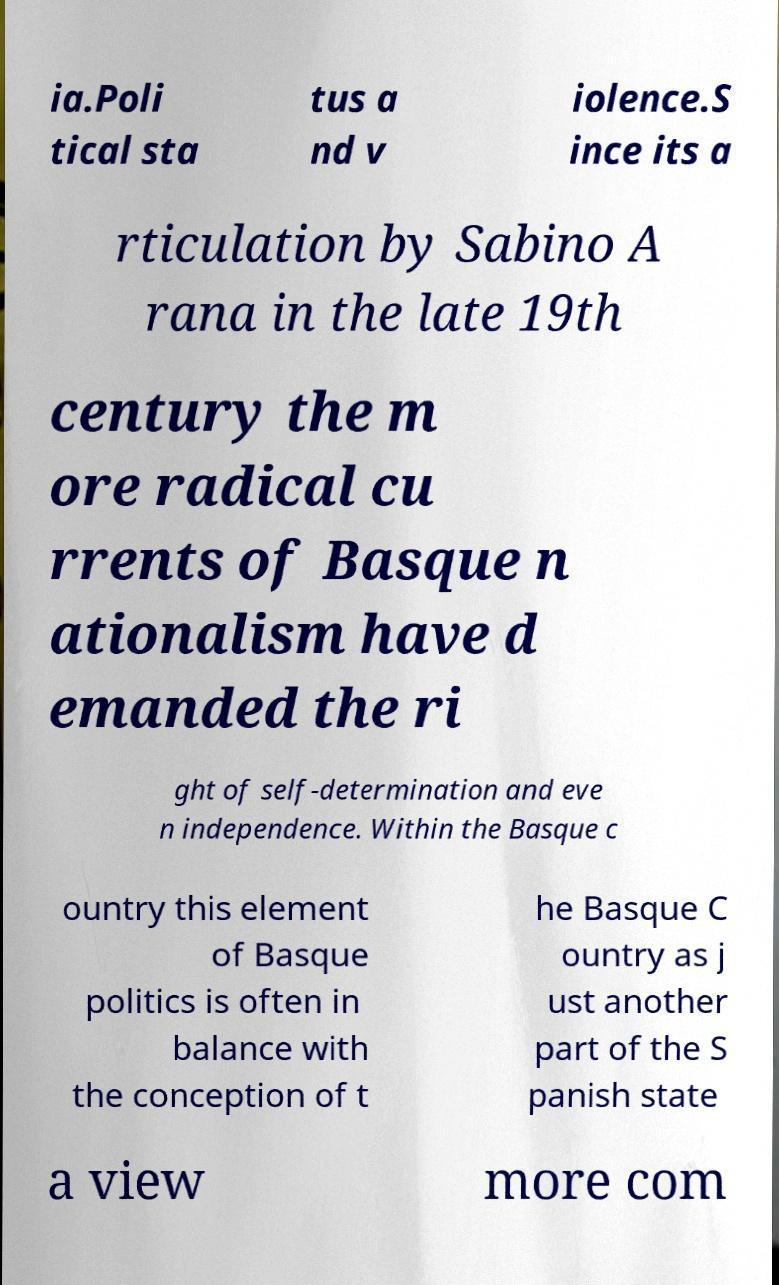What messages or text are displayed in this image? I need them in a readable, typed format. ia.Poli tical sta tus a nd v iolence.S ince its a rticulation by Sabino A rana in the late 19th century the m ore radical cu rrents of Basque n ationalism have d emanded the ri ght of self-determination and eve n independence. Within the Basque c ountry this element of Basque politics is often in balance with the conception of t he Basque C ountry as j ust another part of the S panish state a view more com 